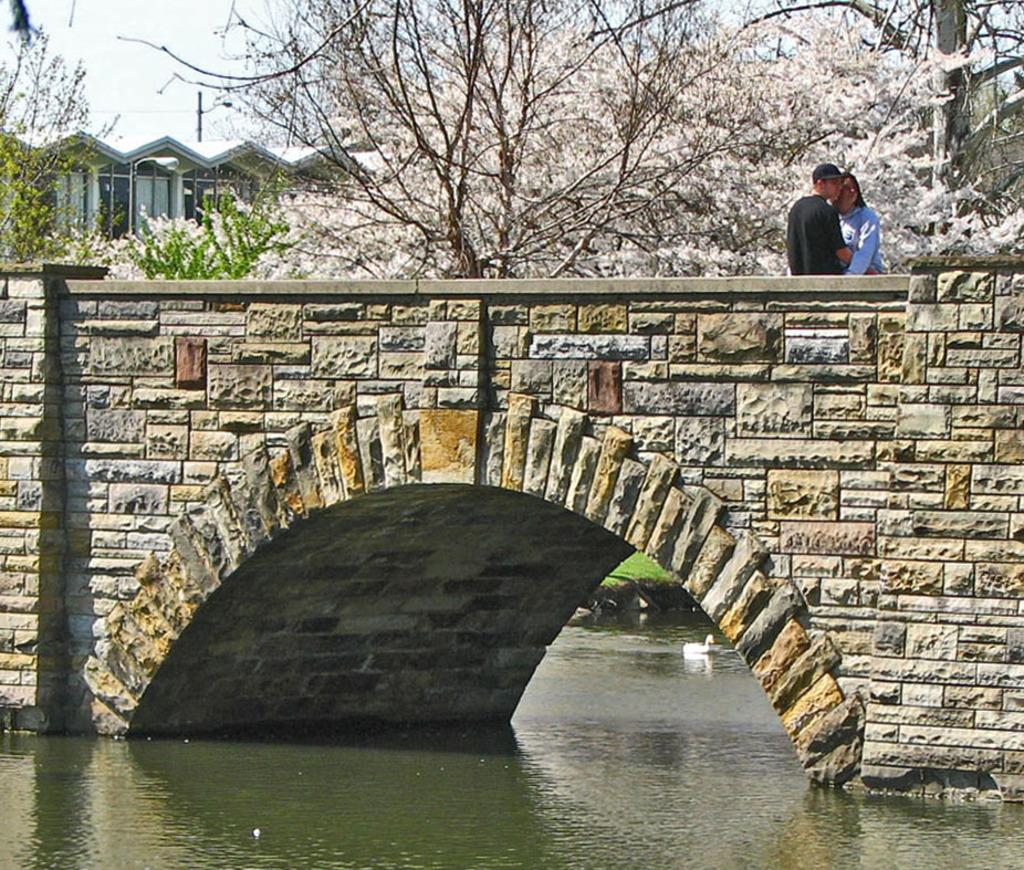What is the bird doing in the image? The bird is on the water in the image. Where are the two persons located in the image? The two persons are on a bridge in the image. What can be seen in the background of the image? There are trees, a building, a pole, and clouds in the sky in the background of the image. What type of meal is the bird eating on the water in the image? There is no meal present in the image; the bird is simply on the water. How much does the pole weigh in the image? The weight of the pole cannot be determined from the image, as it is not a living object. 